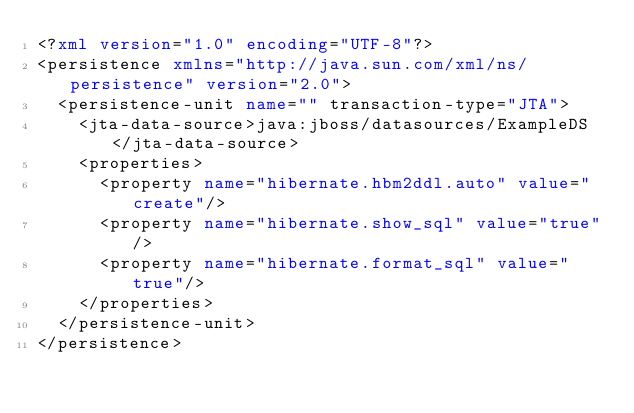<code> <loc_0><loc_0><loc_500><loc_500><_XML_><?xml version="1.0" encoding="UTF-8"?>
<persistence xmlns="http://java.sun.com/xml/ns/persistence" version="2.0">
  <persistence-unit name="" transaction-type="JTA">
    <jta-data-source>java:jboss/datasources/ExampleDS</jta-data-source>
    <properties>
      <property name="hibernate.hbm2ddl.auto" value="create"/>
      <property name="hibernate.show_sql" value="true"/>
      <property name="hibernate.format_sql" value="true"/>
    </properties>
  </persistence-unit>
</persistence>
</code> 